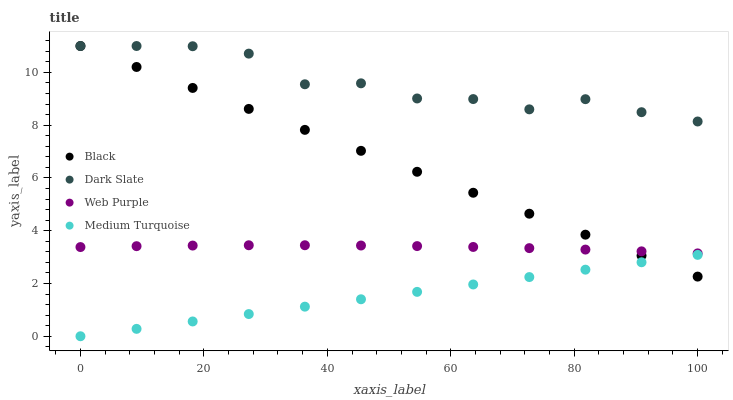Does Medium Turquoise have the minimum area under the curve?
Answer yes or no. Yes. Does Dark Slate have the maximum area under the curve?
Answer yes or no. Yes. Does Web Purple have the minimum area under the curve?
Answer yes or no. No. Does Web Purple have the maximum area under the curve?
Answer yes or no. No. Is Medium Turquoise the smoothest?
Answer yes or no. Yes. Is Dark Slate the roughest?
Answer yes or no. Yes. Is Web Purple the smoothest?
Answer yes or no. No. Is Web Purple the roughest?
Answer yes or no. No. Does Medium Turquoise have the lowest value?
Answer yes or no. Yes. Does Web Purple have the lowest value?
Answer yes or no. No. Does Black have the highest value?
Answer yes or no. Yes. Does Web Purple have the highest value?
Answer yes or no. No. Is Web Purple less than Dark Slate?
Answer yes or no. Yes. Is Dark Slate greater than Web Purple?
Answer yes or no. Yes. Does Black intersect Medium Turquoise?
Answer yes or no. Yes. Is Black less than Medium Turquoise?
Answer yes or no. No. Is Black greater than Medium Turquoise?
Answer yes or no. No. Does Web Purple intersect Dark Slate?
Answer yes or no. No. 